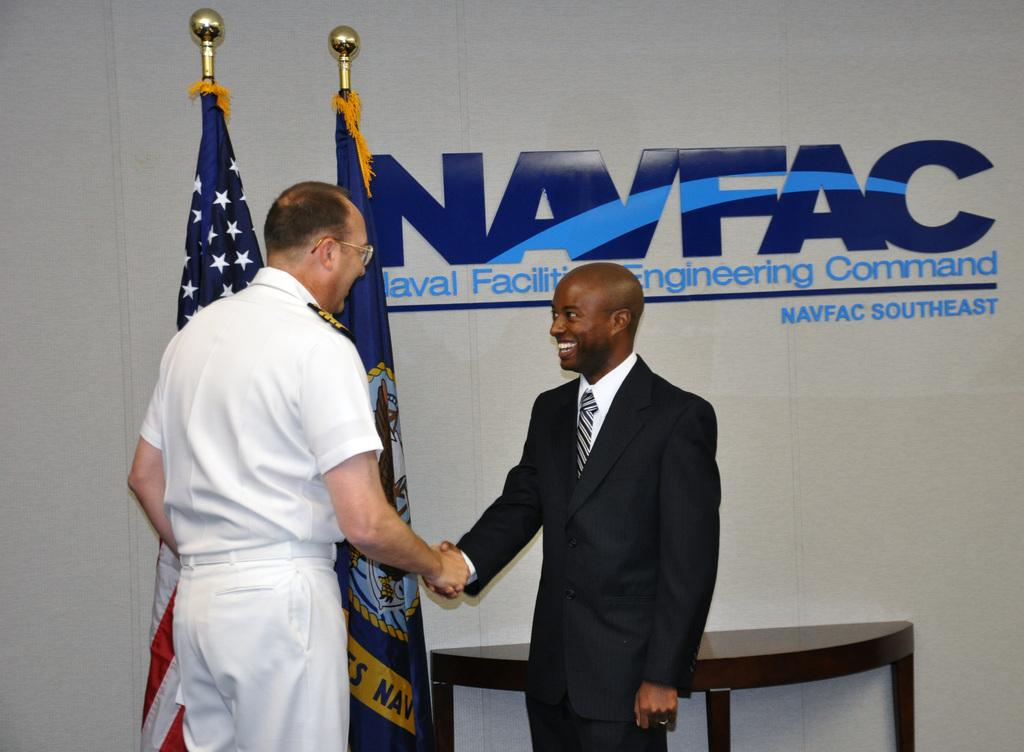<image>
Create a compact narrative representing the image presented. Two men shake hands in front of a wall that identifies the location as the Naval Facilities Engineering Command. 